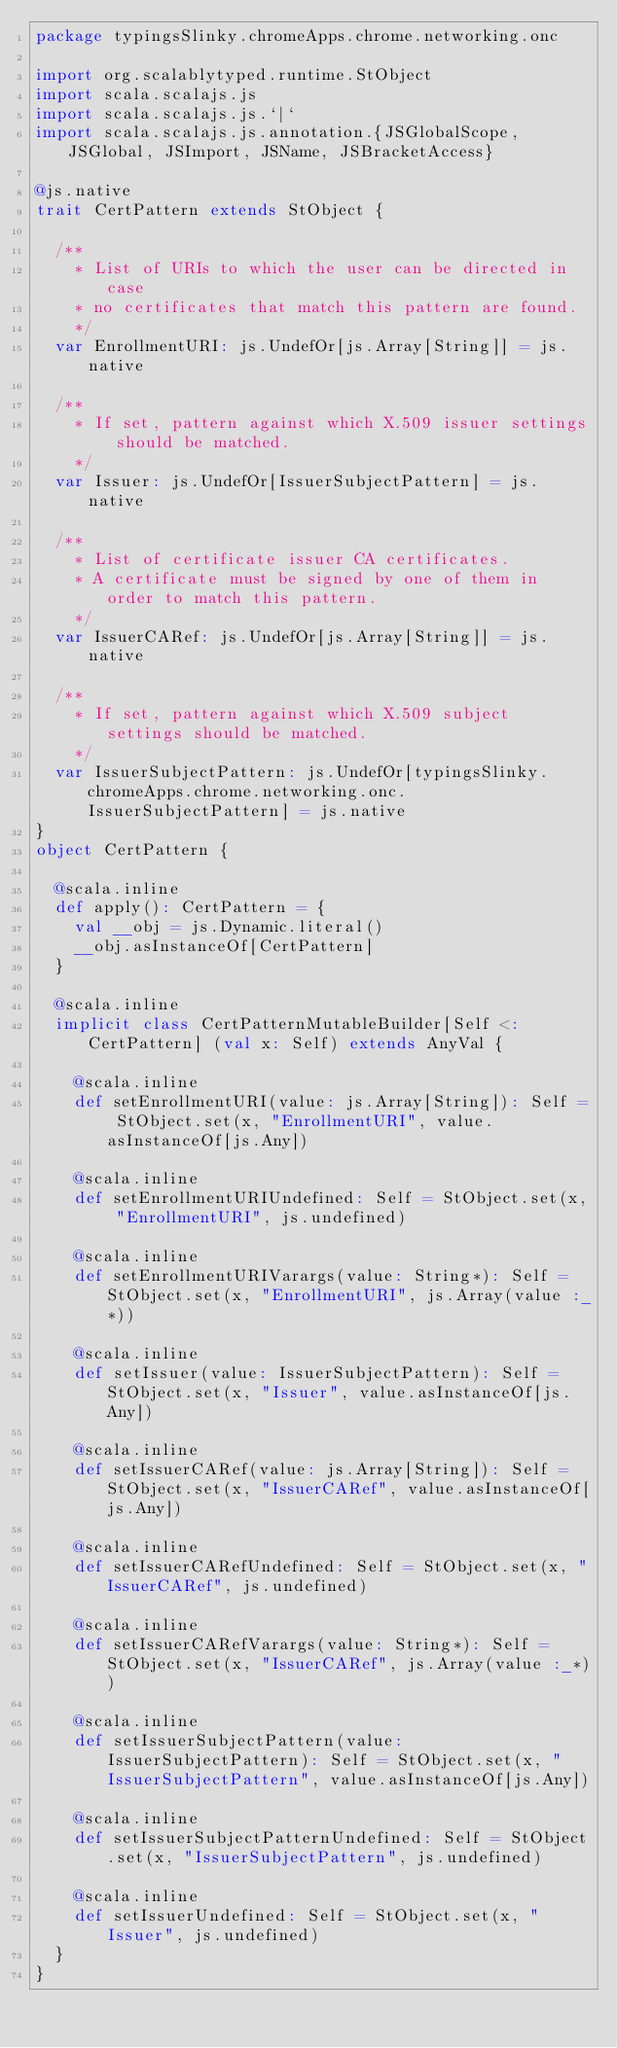Convert code to text. <code><loc_0><loc_0><loc_500><loc_500><_Scala_>package typingsSlinky.chromeApps.chrome.networking.onc

import org.scalablytyped.runtime.StObject
import scala.scalajs.js
import scala.scalajs.js.`|`
import scala.scalajs.js.annotation.{JSGlobalScope, JSGlobal, JSImport, JSName, JSBracketAccess}

@js.native
trait CertPattern extends StObject {
  
  /**
    * List of URIs to which the user can be directed in case
    * no certificates that match this pattern are found.
    */
  var EnrollmentURI: js.UndefOr[js.Array[String]] = js.native
  
  /**
    * If set, pattern against which X.509 issuer settings should be matched.
    */
  var Issuer: js.UndefOr[IssuerSubjectPattern] = js.native
  
  /**
    * List of certificate issuer CA certificates.
    * A certificate must be signed by one of them in order to match this pattern.
    */
  var IssuerCARef: js.UndefOr[js.Array[String]] = js.native
  
  /**
    * If set, pattern against which X.509 subject settings should be matched.
    */
  var IssuerSubjectPattern: js.UndefOr[typingsSlinky.chromeApps.chrome.networking.onc.IssuerSubjectPattern] = js.native
}
object CertPattern {
  
  @scala.inline
  def apply(): CertPattern = {
    val __obj = js.Dynamic.literal()
    __obj.asInstanceOf[CertPattern]
  }
  
  @scala.inline
  implicit class CertPatternMutableBuilder[Self <: CertPattern] (val x: Self) extends AnyVal {
    
    @scala.inline
    def setEnrollmentURI(value: js.Array[String]): Self = StObject.set(x, "EnrollmentURI", value.asInstanceOf[js.Any])
    
    @scala.inline
    def setEnrollmentURIUndefined: Self = StObject.set(x, "EnrollmentURI", js.undefined)
    
    @scala.inline
    def setEnrollmentURIVarargs(value: String*): Self = StObject.set(x, "EnrollmentURI", js.Array(value :_*))
    
    @scala.inline
    def setIssuer(value: IssuerSubjectPattern): Self = StObject.set(x, "Issuer", value.asInstanceOf[js.Any])
    
    @scala.inline
    def setIssuerCARef(value: js.Array[String]): Self = StObject.set(x, "IssuerCARef", value.asInstanceOf[js.Any])
    
    @scala.inline
    def setIssuerCARefUndefined: Self = StObject.set(x, "IssuerCARef", js.undefined)
    
    @scala.inline
    def setIssuerCARefVarargs(value: String*): Self = StObject.set(x, "IssuerCARef", js.Array(value :_*))
    
    @scala.inline
    def setIssuerSubjectPattern(value: IssuerSubjectPattern): Self = StObject.set(x, "IssuerSubjectPattern", value.asInstanceOf[js.Any])
    
    @scala.inline
    def setIssuerSubjectPatternUndefined: Self = StObject.set(x, "IssuerSubjectPattern", js.undefined)
    
    @scala.inline
    def setIssuerUndefined: Self = StObject.set(x, "Issuer", js.undefined)
  }
}
</code> 